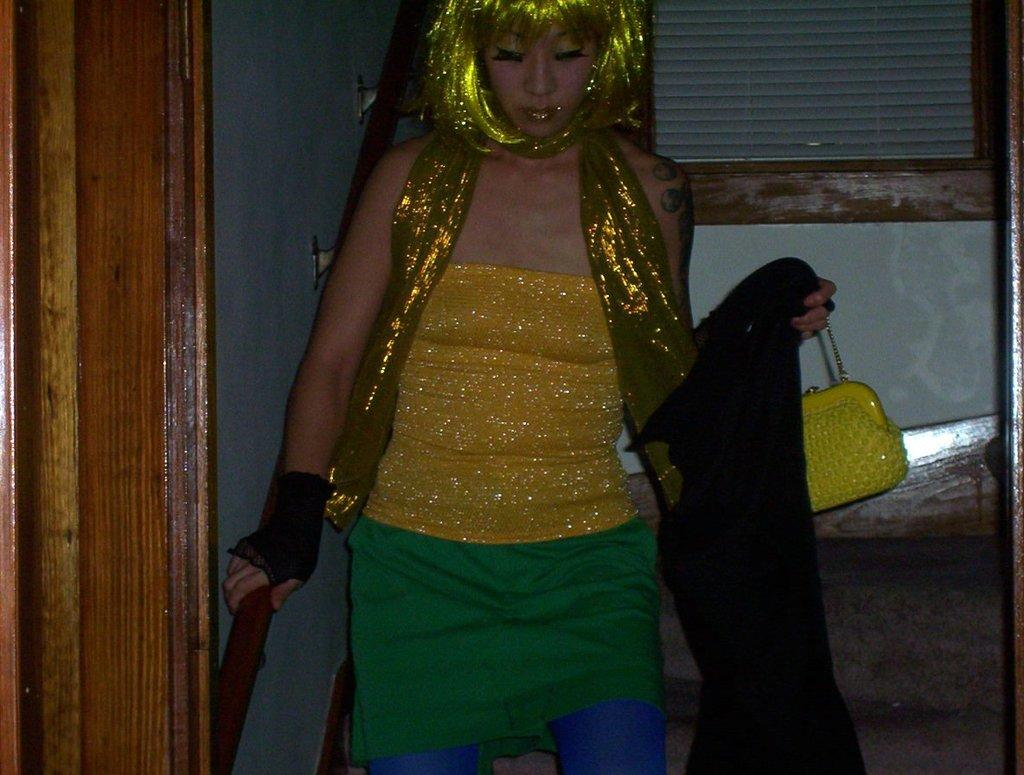Who is present in the image? There is a woman in the image. What is the woman holding in the image? The woman is holding a bag. What is unique about the woman's appearance? The woman's hair is green. What can be seen to the left of the image? There is a door to the left of the image. What is visible in the background of the image? There is a wall in the background of the image. What type of cake is being drawn on the wall with chalk in the image? There is no cake or chalk present in the image; the wall in the background is plain. 